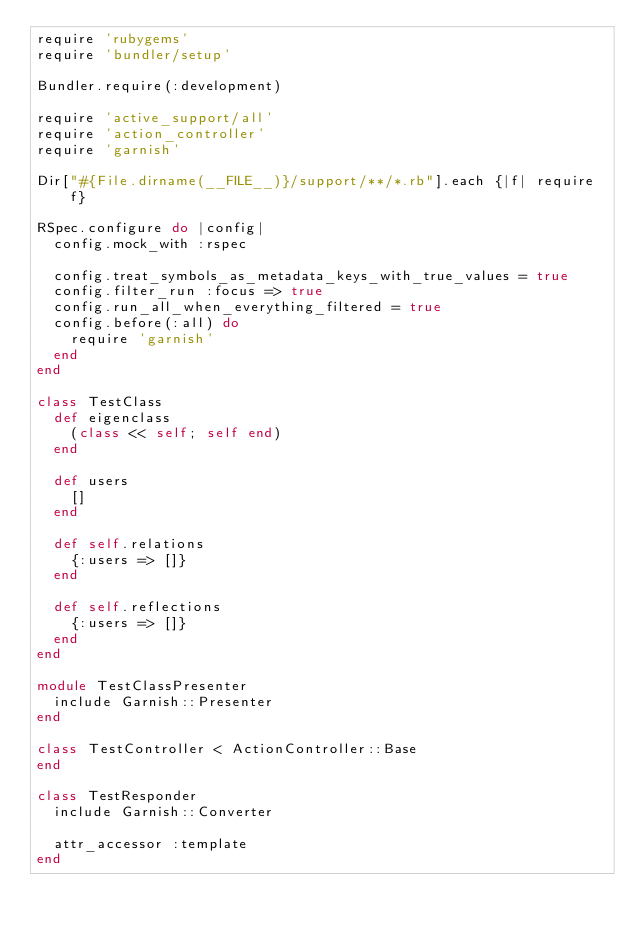Convert code to text. <code><loc_0><loc_0><loc_500><loc_500><_Ruby_>require 'rubygems'
require 'bundler/setup'

Bundler.require(:development)

require 'active_support/all'
require 'action_controller'
require 'garnish'

Dir["#{File.dirname(__FILE__)}/support/**/*.rb"].each {|f| require f}

RSpec.configure do |config|
  config.mock_with :rspec

  config.treat_symbols_as_metadata_keys_with_true_values = true
  config.filter_run :focus => true
  config.run_all_when_everything_filtered = true
  config.before(:all) do
    require 'garnish'
  end
end

class TestClass
  def eigenclass
    (class << self; self end)
  end

  def users
    []
  end

  def self.relations
    {:users => []}
  end

  def self.reflections
    {:users => []}
  end
end

module TestClassPresenter
  include Garnish::Presenter
end

class TestController < ActionController::Base
end

class TestResponder
  include Garnish::Converter

  attr_accessor :template
end
</code> 